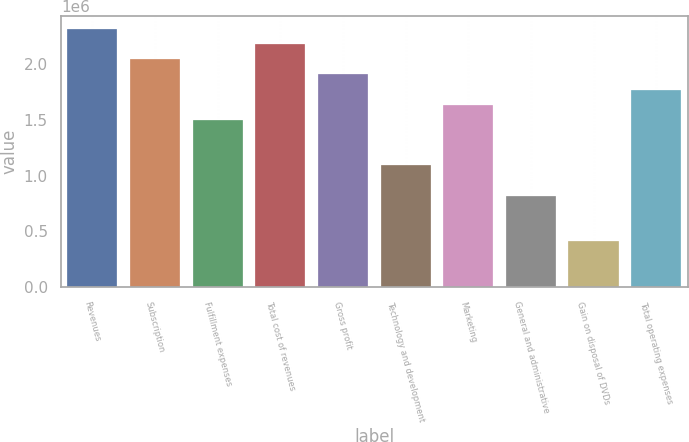Convert chart. <chart><loc_0><loc_0><loc_500><loc_500><bar_chart><fcel>Revenues<fcel>Subscription<fcel>Fulfillment expenses<fcel>Total cost of revenues<fcel>Gross profit<fcel>Technology and development<fcel>Marketing<fcel>General and administrative<fcel>Gain on disposal of DVDs<fcel>Total operating expenses<nl><fcel>2.31992e+06<fcel>2.04699e+06<fcel>1.50113e+06<fcel>2.18346e+06<fcel>1.91052e+06<fcel>1.09173e+06<fcel>1.63759e+06<fcel>818797<fcel>409399<fcel>1.77406e+06<nl></chart> 